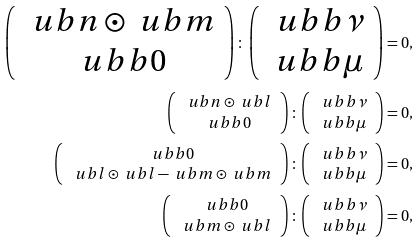Convert formula to latex. <formula><loc_0><loc_0><loc_500><loc_500>\left ( \begin{array} { c } \ u b n \odot \ u b m \\ \ u b b 0 \end{array} \right ) \colon \left ( \begin{array} { c } \ u b b \nu \\ \ u b b \mu \end{array} \right ) = 0 , \\ \left ( \begin{array} { c } \ u b n \odot \ u b l \\ \ u b b 0 \end{array} \right ) \colon \left ( \begin{array} { c } \ u b b \nu \\ \ u b b \mu \end{array} \right ) = 0 , \\ \left ( \begin{array} { c } \ u b b 0 \\ \ u b l \odot \ u b l - \ u b m \odot \ u b m \end{array} \right ) \colon \left ( \begin{array} { c } \ u b b \nu \\ \ u b b \mu \end{array} \right ) = 0 , \\ \left ( \begin{array} { c } \ u b b 0 \\ \ u b m \odot \ u b l \end{array} \right ) \colon \left ( \begin{array} { c } \ u b b \nu \\ \ u b b \mu \end{array} \right ) = 0 ,</formula> 